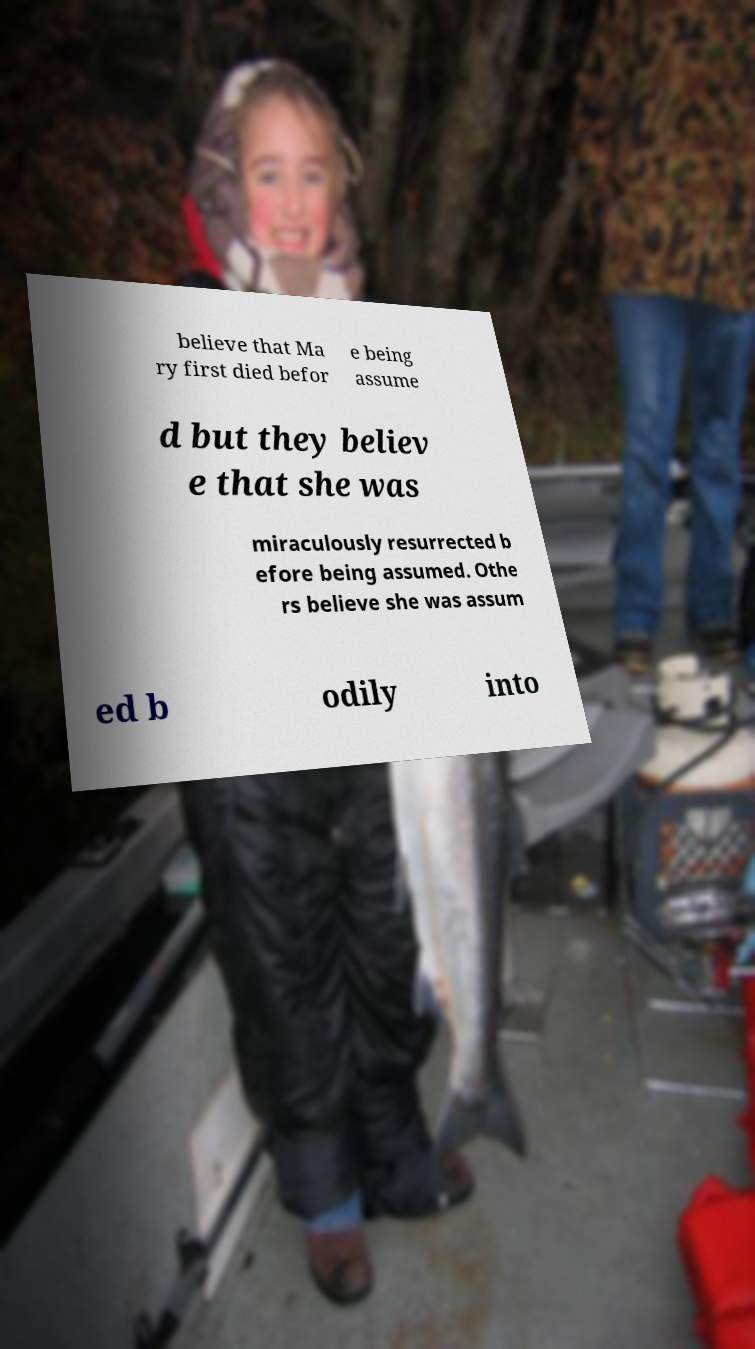For documentation purposes, I need the text within this image transcribed. Could you provide that? believe that Ma ry first died befor e being assume d but they believ e that she was miraculously resurrected b efore being assumed. Othe rs believe she was assum ed b odily into 